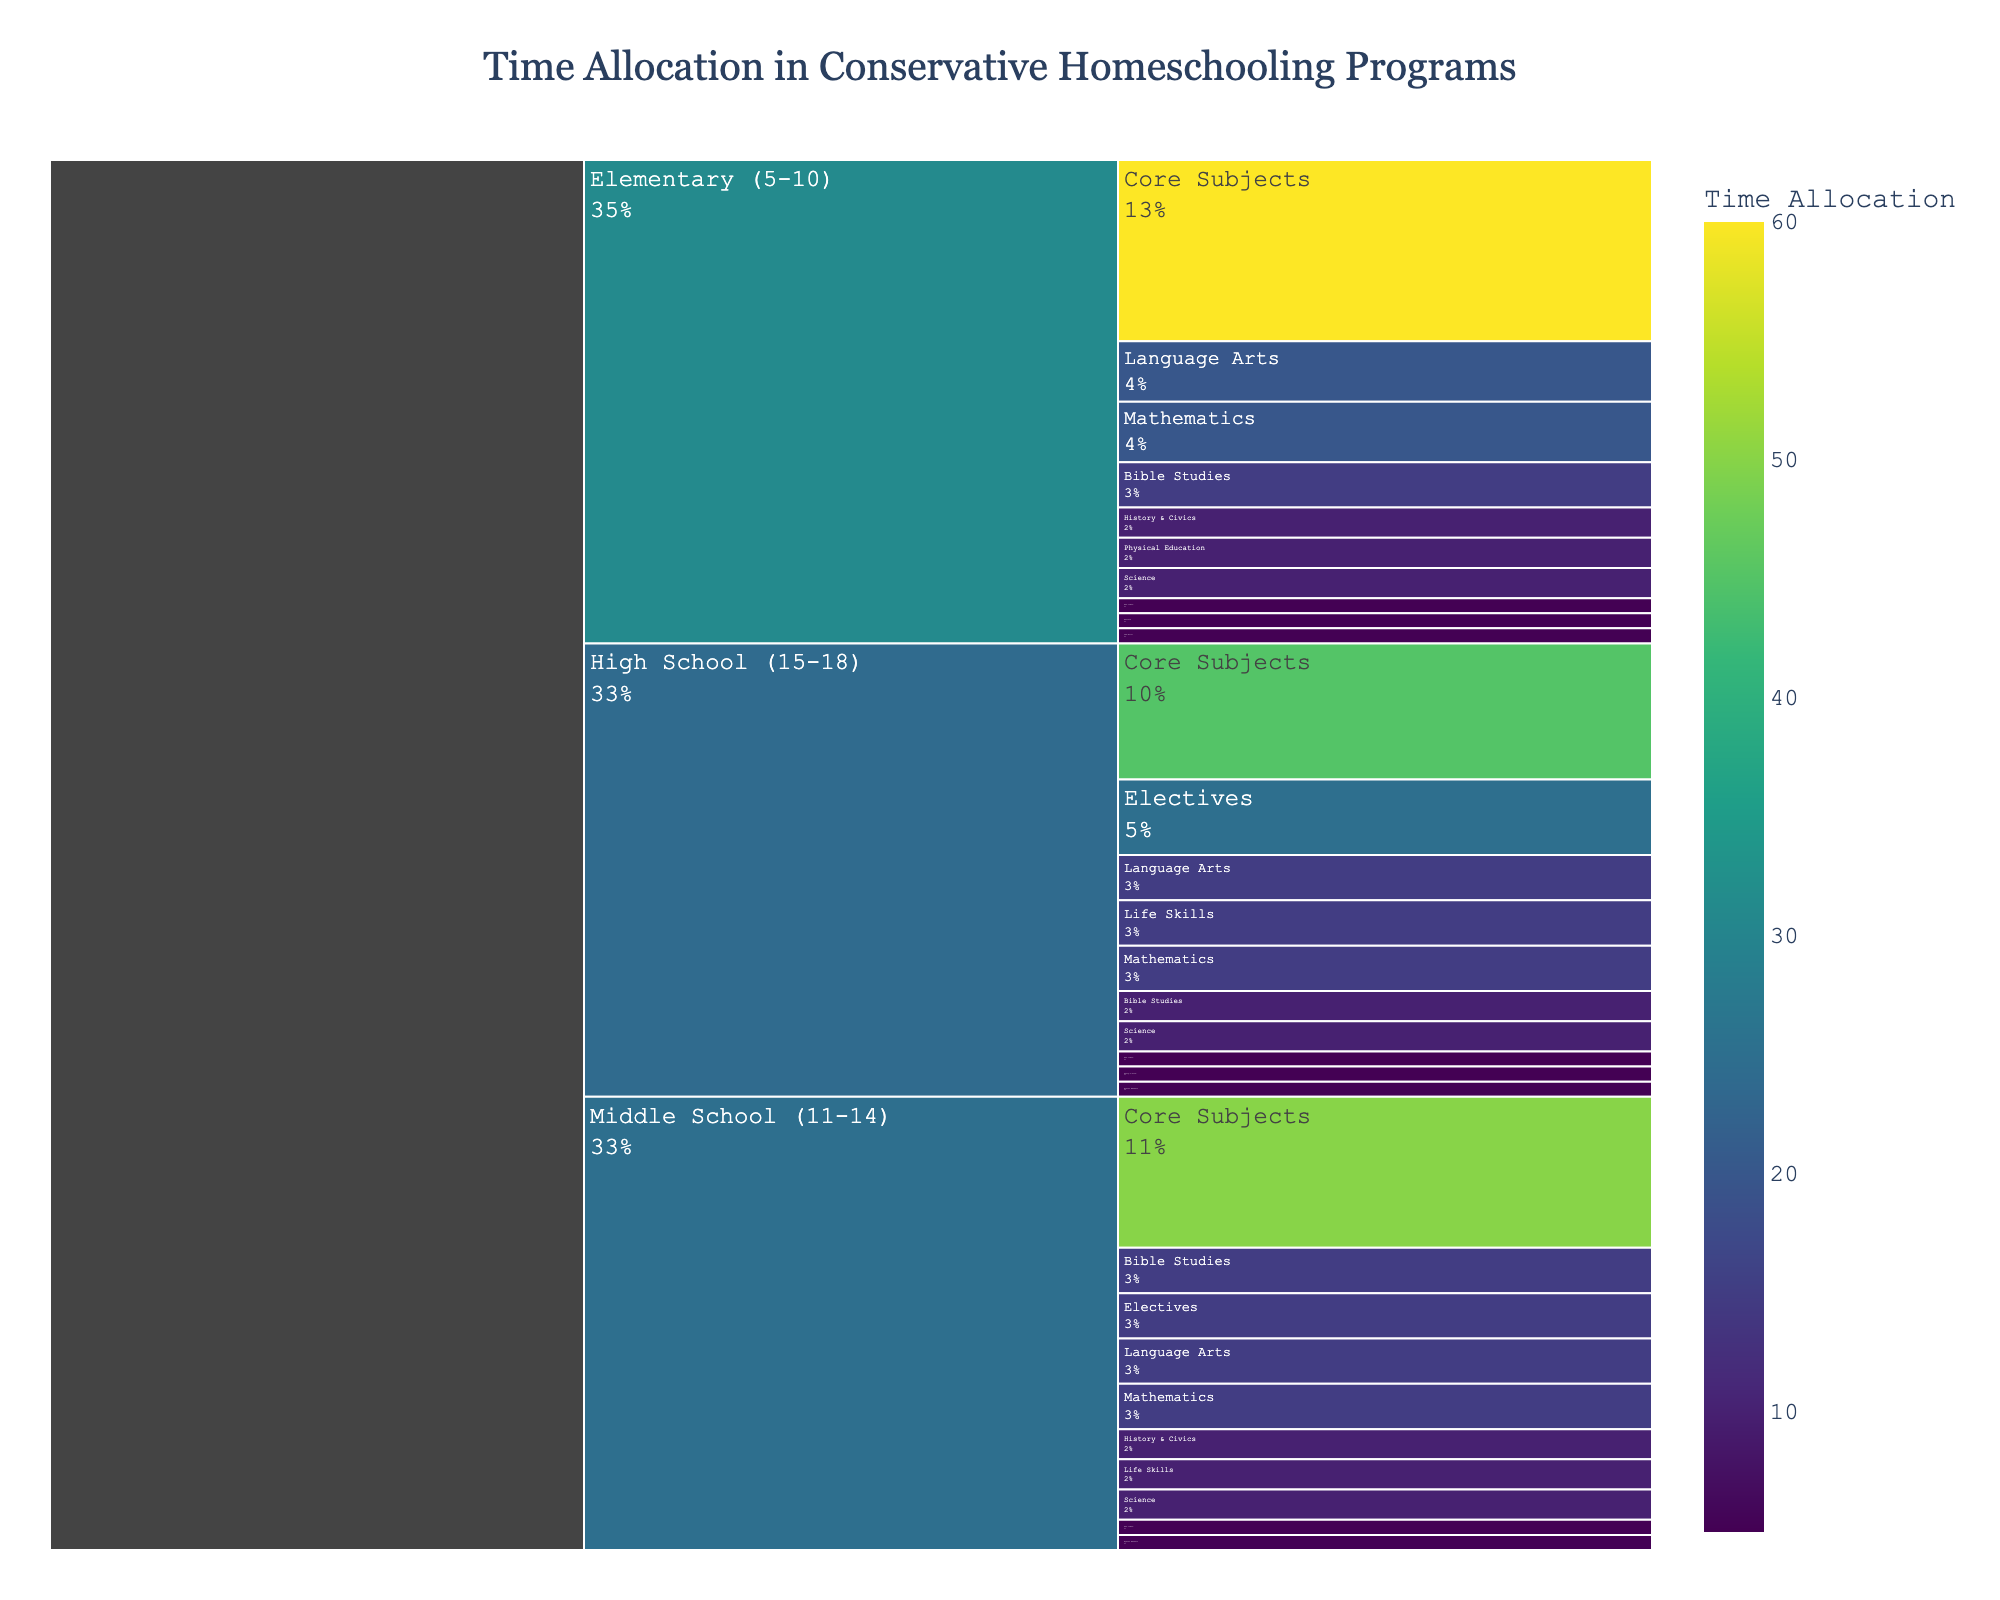What is the title of the figure? The title of the figure is displayed at the top center of the chart. It provides a summary of the visualized data.
Answer: Time Allocation in Conservative Homeschooling Programs Which age group spends the most time on Core Subjects? Locate the "Core Subjects" section and compare its size across the three age groups. The largest section indicates the highest time allocation.
Answer: Elementary (5-10) What percentage of time is allocated to Bible Studies for High School students? Find the "Bible Studies" section under "High School (15-18)" and note the percentage displayed within the color-coded box.
Answer: 10% How much more time is allocated to Mathematics in Elementary compared to Middle School? Identify the "Mathematics" sections under both "Elementary (5-10)" and "Middle School (11-14)," then calculate the difference between their time allocations (20 - 15).
Answer: 5 How does the time allocation for Physical Education change from Elementary to High School? Track the "Physical Education" sections across "Elementary (5-10)," "Middle School (11-14)," and "High School (15-18)" and observe the changes in time allocation. The time stays constant from Middle School to High School.
Answer: Decreases by 5 units from Elementary to Middle School and stays the same to High School What are the three subjects with the smallest time allocation in High School? Look under "High School (15-18)" and identify the three subjects with the smallest sections.
Answer: History & Civics, Physical Education, Arts & Music What is the total time allocation for Electives across all age groups? Add the time allocations for "Electives" in all age groups: 5 (Elementary) + 15 (Middle School) + 25 (High School).
Answer: 45 Which subject has an equal time allocation in both Middle School and High School? Compare the sections under "Middle School (11-14)" and "High School (15-18)" to find the subject with matching time values.
Answer: Bible Studies, Mathematics, Language Arts, and Science What's the combined time allocation for 'Arts & Music' and 'Life Skills' in Middle School? Summing up the time for "Arts & Music" and "Life Skills" under "Middle School (11-14)" gives: 5 + 10.
Answer: 15 Between which two age groups does time allocation for Life Skills change the most? Calculate the difference in time allocation for "Life Skills" between each consecutive age group: (10-5) from Elementary to Middle School and (15-10) from Middle School to High School.
Answer: Middle School to High School 